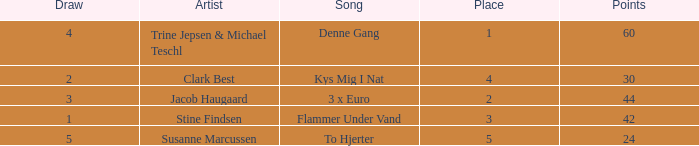What is the lowest Draw when the Artist is Stine Findsen and the Points are larger than 42? None. 